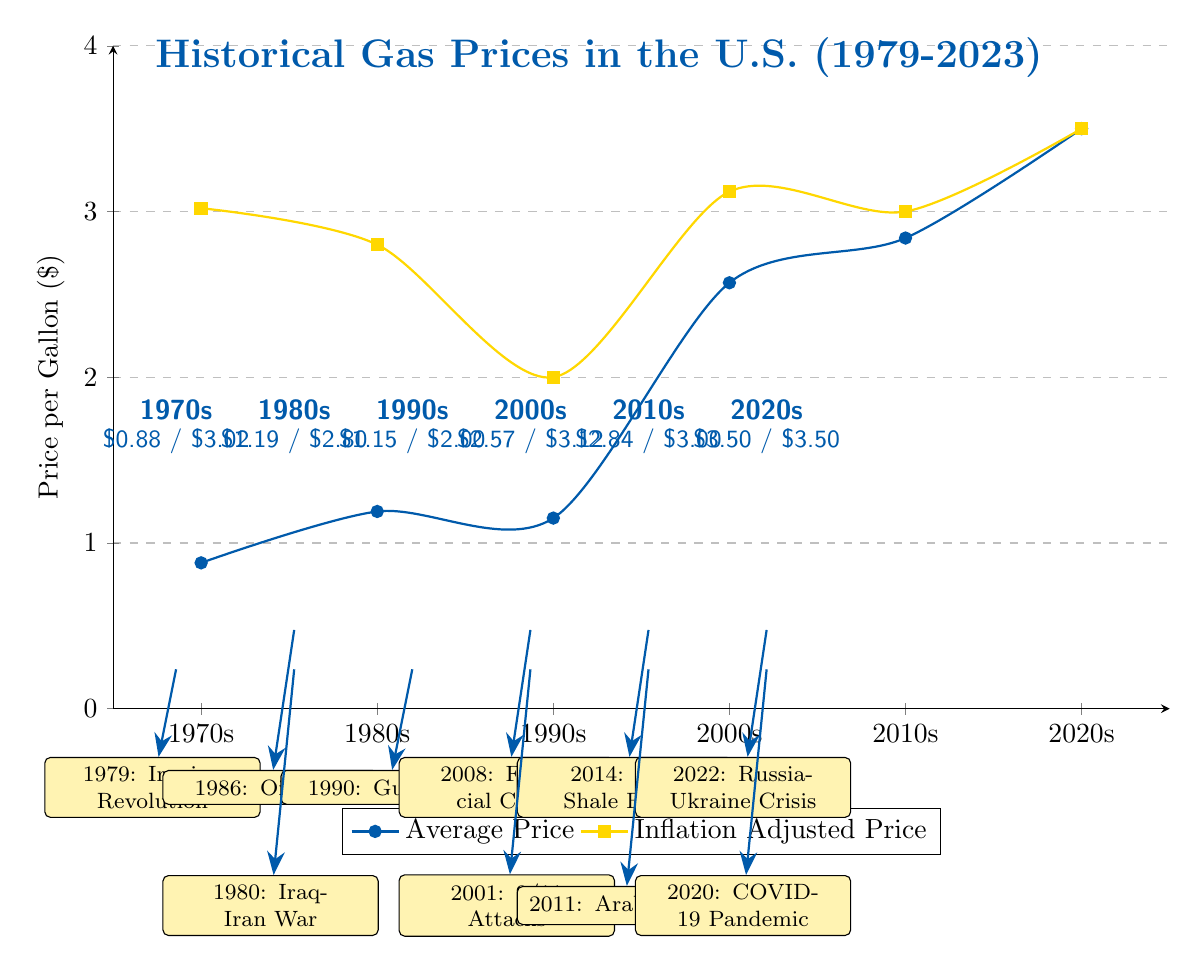What was the average gas price in the 1980s? The average gas price for the 1980s is indicated on the y-axis at the coordinate where the x-axis represents the 1980s, which shows $1.19.
Answer: $1.19 What significant event happened in 2008? The event labeled under the 2000s decade is "2008: Financial Crisis," which signifies an important historical event affecting gas prices.
Answer: Financial Crisis What is the inflation-adjusted price in the 1990s? The inflation-adjusted price for the 1990s is noted at the coordinate for the 1990s on the second data series, which is $2.00.
Answer: $2.00 How did the average price in the 1970s compare to the average price in the 2010s? The average price in the 1970s was $0.88, and in the 2010s, it was $2.84. The difference can be calculated by comparing these values.
Answer: $0.88 vs. $2.84 What decade has the highest inflation-adjusted price? By examining the inflation-adjusted prices across decades, the 2000s have the highest inflation-adjusted price listed as $3.12.
Answer: 2000s Which two events are noted in the 2010s? The events shown for the 2010s are "2011: Arab Spring" and "2014: U.S. Shale Boom." These events are labeled as influencing factors within that decade.
Answer: Arab Spring, U.S. Shale Boom What is the average price for the 2020s? The diagram indicates the average gas price for the 2020s at $3.50, which is represented on the graph's last data point.
Answer: $3.50 In which decade did the oil glut occur? The oil glut event is recorded in the 1980s, as labeled in the diagram for the year 1986.
Answer: 1980s How many major historical events are depicted in the diagram? Upon counting the events listed, there are a total of 10 major historical events illustrated in the diagram affecting gas prices from 1979 to 2023.
Answer: 10 